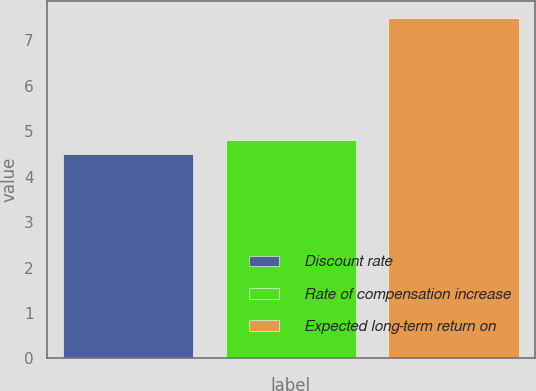<chart> <loc_0><loc_0><loc_500><loc_500><bar_chart><fcel>Discount rate<fcel>Rate of compensation increase<fcel>Expected long-term return on<nl><fcel>4.5<fcel>4.8<fcel>7.5<nl></chart> 